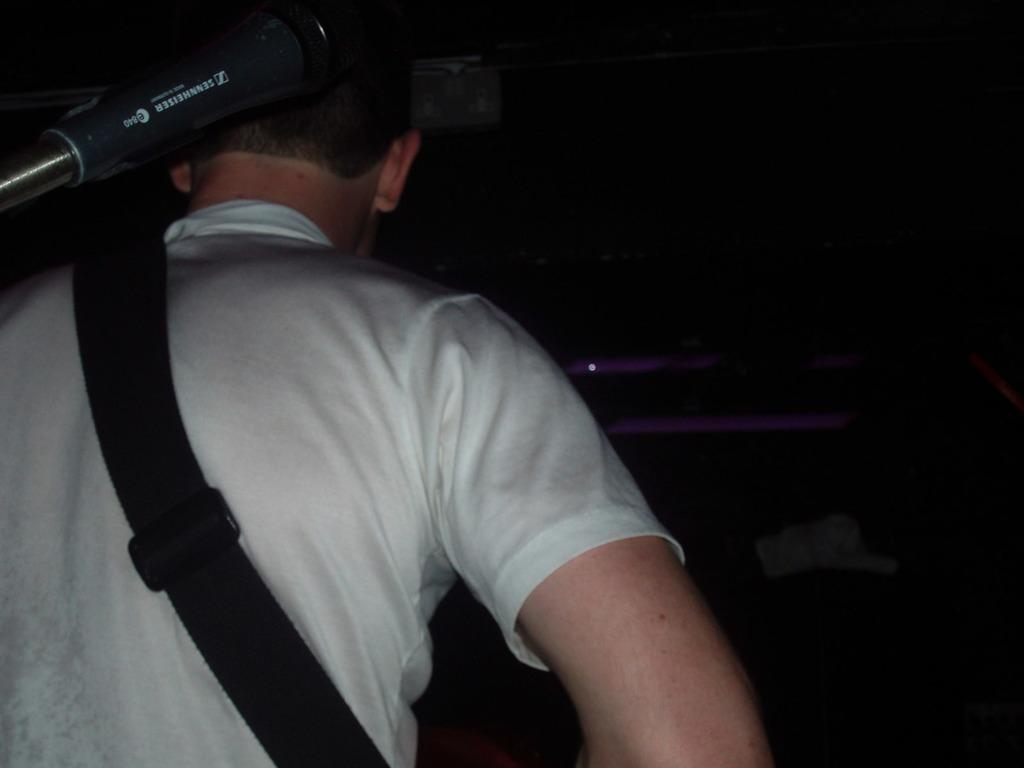Who or what is present in the image? There is a person in the image. What is the person wearing? The person is wearing a white t-shirt. What is the person holding or carrying? The person is carrying a bag. What type of stone can be seen in the person's hand in the image? There is no stone present in the person's hand or anywhere in the image. 